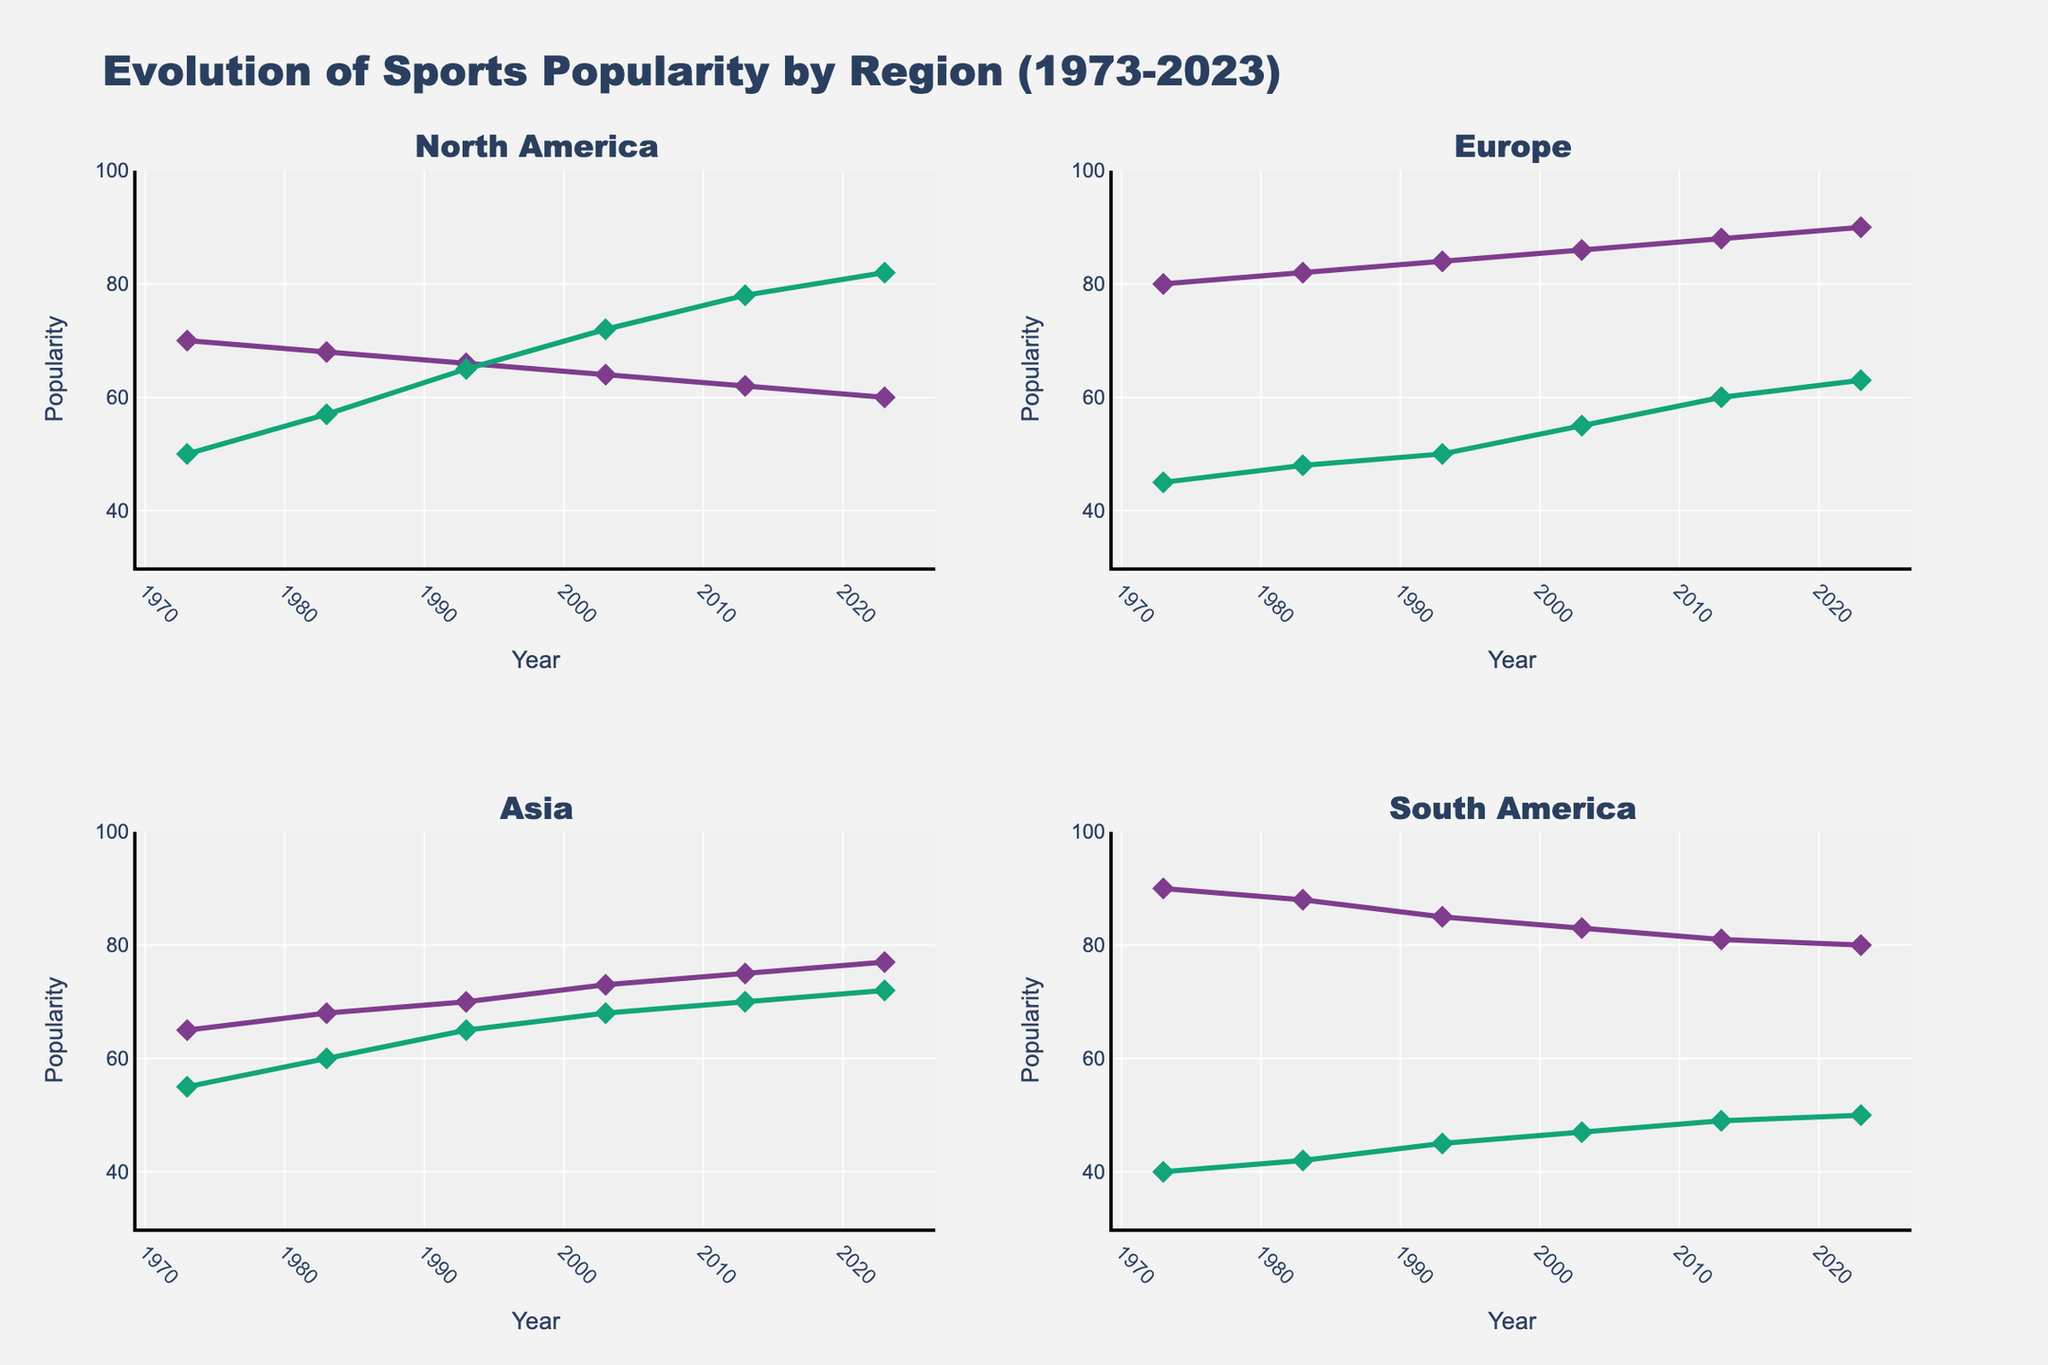What is the title of the plot? The title of the plot is prominently displayed at the top. We can directly refer to it to find the title.
Answer: Evolution of Sports Popularity by Region (1973-2023) On the X-axis, what variable is being displayed and what are its units? The X-axis shows the time variable, indicated by the labels and title on the axis.
Answer: Year Which region shows the highest popularity for Soccer in 2023? Examine each subplot for the year 2023 and compare the popularity values for Soccer in the respective regions. The highest value should be selected.
Answer: Europe By how much did the popularity of American Football increase in North America from 1973 to 2023? Check the North America subplot for American Football in the years 1973 and 2023. Subtract the 1973 value from the 2023 value to find the increase.
Answer: 32 Which sport in Asia shows the most steady trend in popularity over the 50-year period? Look at the line trends for each sport in the Asia subplot. The most steady trend will have the least fluctuations in the line.
Answer: Cricket How does the popularity of Volleyball in South America compare between 1983 and 2013? Locate the popularity values for Volleyball in the South America subplot for the years 1983 and 2013. Compare the two values.
Answer: 42 in 1983, 49 in 2013 Which sport had the highest overall popularity in any region for any given year? Look through each subplot for the peak popularity value across all years and regions. Identify the sport corresponding to this peak value.
Answer: Soccer in South America (1973) Did Table Tennis in Asia ever surpass 70 in popularity over the 50 years? Check the popularity values for Table Tennis in the Asia subplot across all years. Look for values greater than 70.
Answer: Yes (2013, 2023) Which sport in Europe showed the highest increase in popularity from 1973 to 2023? Examine the Europe subplot for the sports and compare their values in 1973 and 2023. Determine which sport had the largest increase by subtracting the 1973 value from the 2023 value for each sport.
Answer: Tennis What is the general trend of Baseball popularity in North America over the 50 years? Analyze the line for Baseball in the North America subplot to determine if it is increasing, decreasing, or remaining stable over time.
Answer: Decreasing 